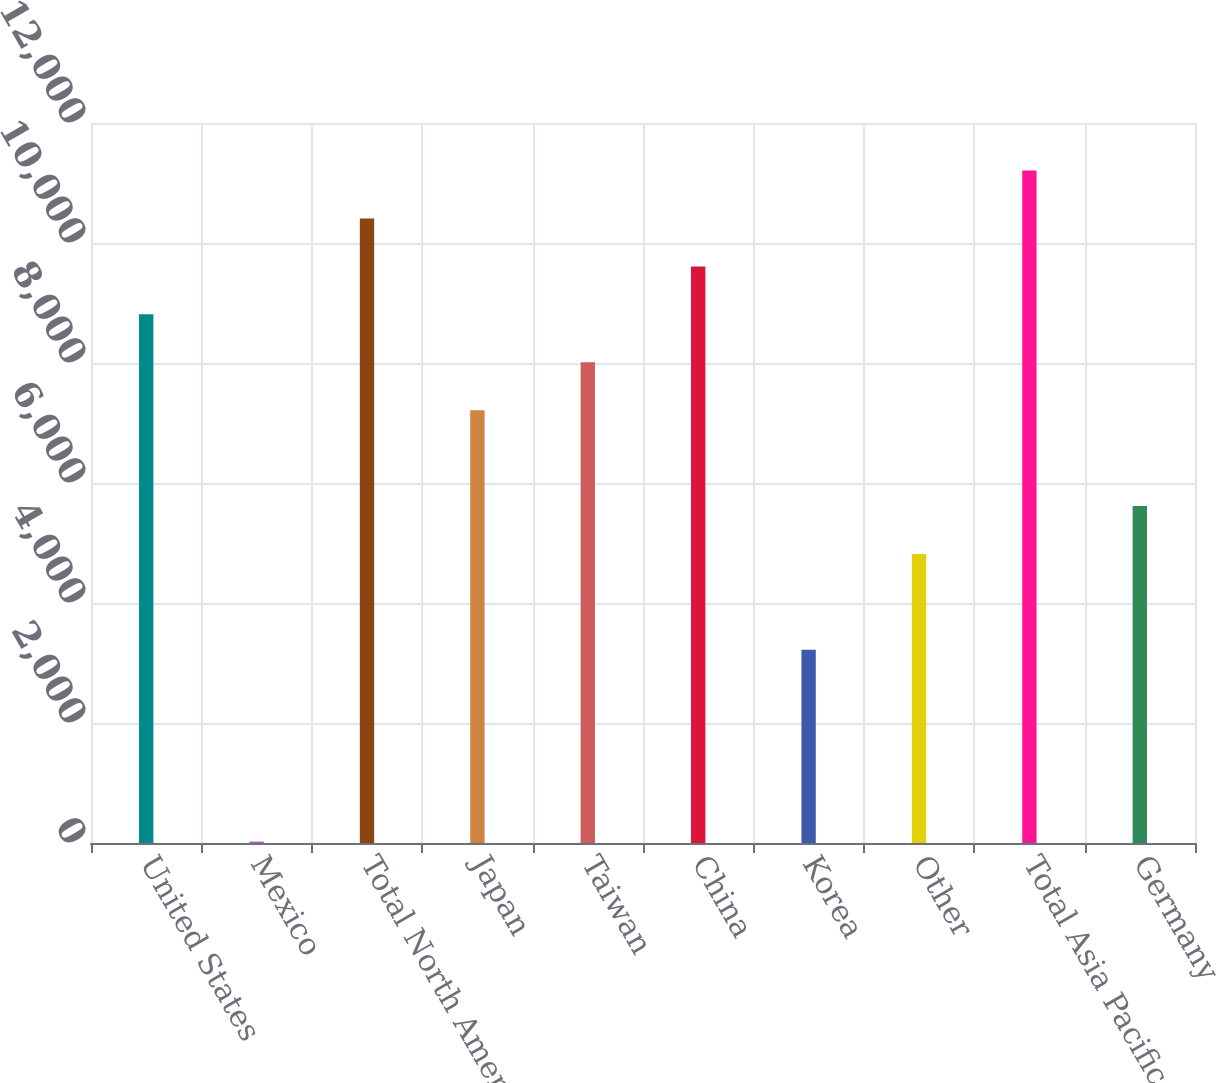<chart> <loc_0><loc_0><loc_500><loc_500><bar_chart><fcel>United States<fcel>Mexico<fcel>Total North America<fcel>Japan<fcel>Taiwan<fcel>China<fcel>Korea<fcel>Other<fcel>Total Asia Pacific<fcel>Germany<nl><fcel>8810.8<fcel>24<fcel>10408.4<fcel>7213.2<fcel>8012<fcel>9609.6<fcel>3219.2<fcel>4816.8<fcel>11207.2<fcel>5615.6<nl></chart> 